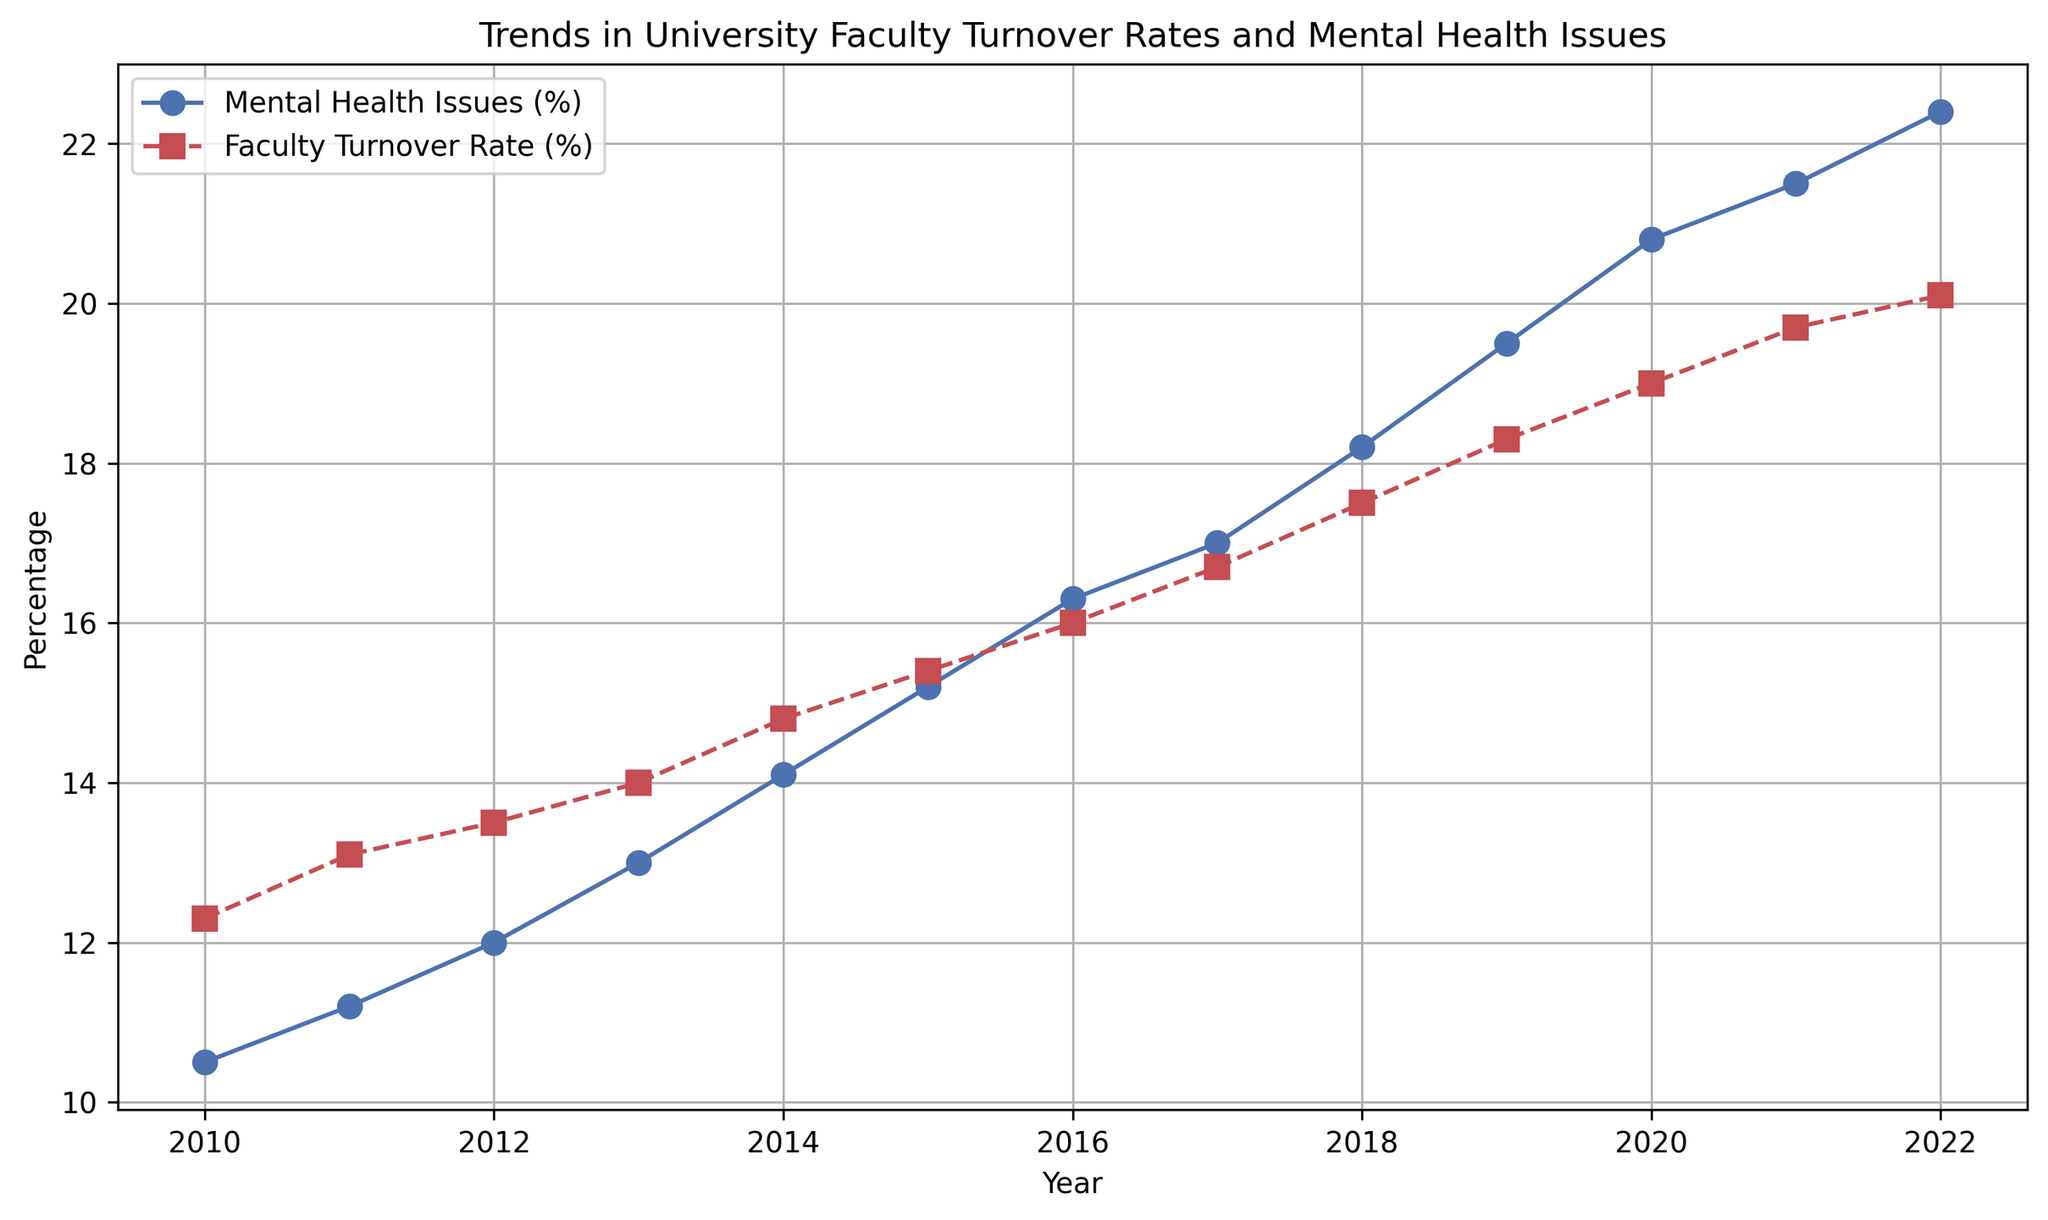What was the turnover rate percentage in 2015? Look for the data point corresponding to 2015 on the line chart of Faculty Turnover Rate (%), which is marked with a red square and a dashed line.
Answer: 15.4 How much did the percentage of mental health issues increase from 2010 to 2022? Find the percentage of mental health issues in 2010 (10.5) and 2022 (22.4), then calculate the difference (22.4 - 10.5).
Answer: 11.9 Which year had a higher percentage of faculty turnover rates: 2016 or 2018? Compare the faculty turnover rates of 2016 (16.0) and 2018 (17.5) using the red line.
Answer: 2018 What is the trend of the mental health issues percentage over time? Observe whether the blue line representing Mental Health Issues Percentage is increasing, decreasing, or staying the same throughout the years. The line shows an upward trend.
Answer: Increasing In which year did both the percentage of mental health issues and faculty turnover rate intersect or are closest to each other? Identify the closest intersection point of the two lines between 2010 and 2022. The closest intersection appears to be around 2010 and 2021. Compare specific values to confirm.
Answer: 2011 What is the average percentage of mental health issues between 2010 and 2015? Add the mental health issues percentages from 2010 to 2015: 10.5 + 11.2 + 12.0 + 13.0 + 14.1 + 15.2. Then divide by 6 (the number of years). The calculation is (10.5 + 11.2 + 12.0 + 13.0 + 14.1 + 15.2) / 6 = 12.67.
Answer: 12.67 By how much did the faculty turnover rate percentage change between 2019 and 2022? Find the faculty turnover rates for 2019 (18.3) and 2022 (20.1), then calculate the difference (20.1 - 18.3).
Answer: 1.8 Which percentage showed a more substantial increase over the period: mental health issues or faculty turnover rates? Calculate the difference from 2010 to 2022 for both mental health issues (22.4 - 10.5 = 11.9) and faculty turnover rates (20.1 - 12.3 = 7.8).
Answer: Mental health issues How does the slope of the mental health issues line compare to the slope of the faculty turnover rates line? Observe the steepness and rate of increase/decrease of the blue and red lines. The blue line (mental health issues) is steeper and increases faster compared to the red line (faculty turnover rates).
Answer: Steeper for mental health issues Do any years show a decrease in faculty turnover rates? Look for downward trends (reductions) in the red dashed line throughout the years. The line does not show a clear decrease in any year.
Answer: No 